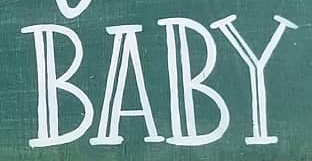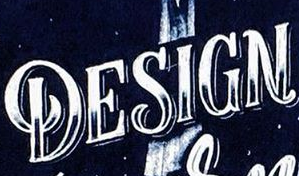Read the text from these images in sequence, separated by a semicolon. BABY; DESIGN 